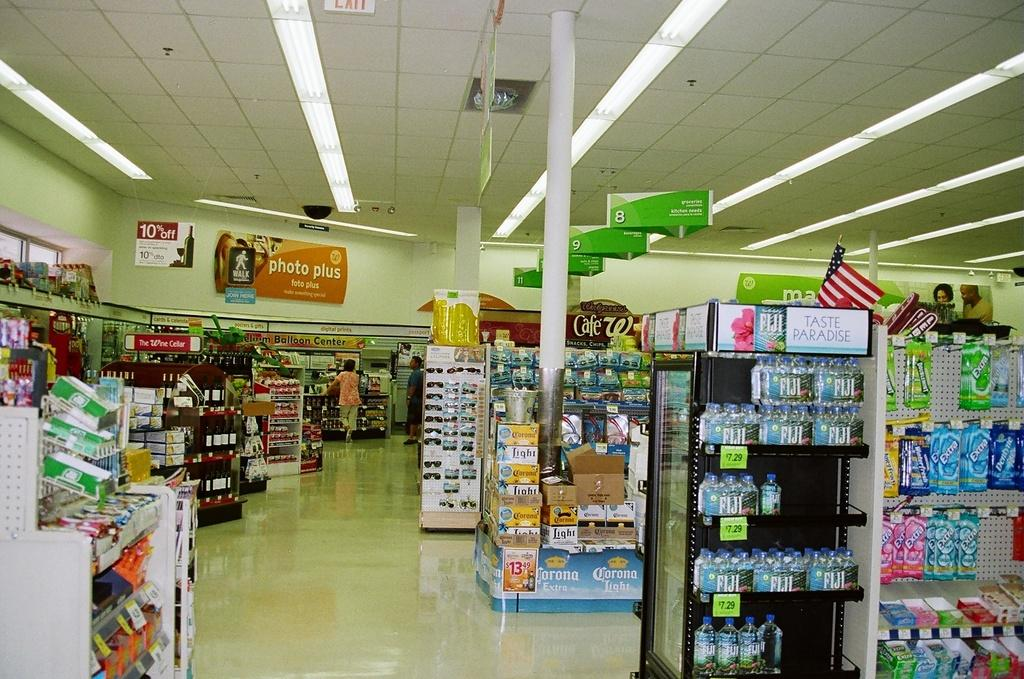<image>
Share a concise interpretation of the image provided. Signs in the store indicate where groceries and other various product categories are located. 